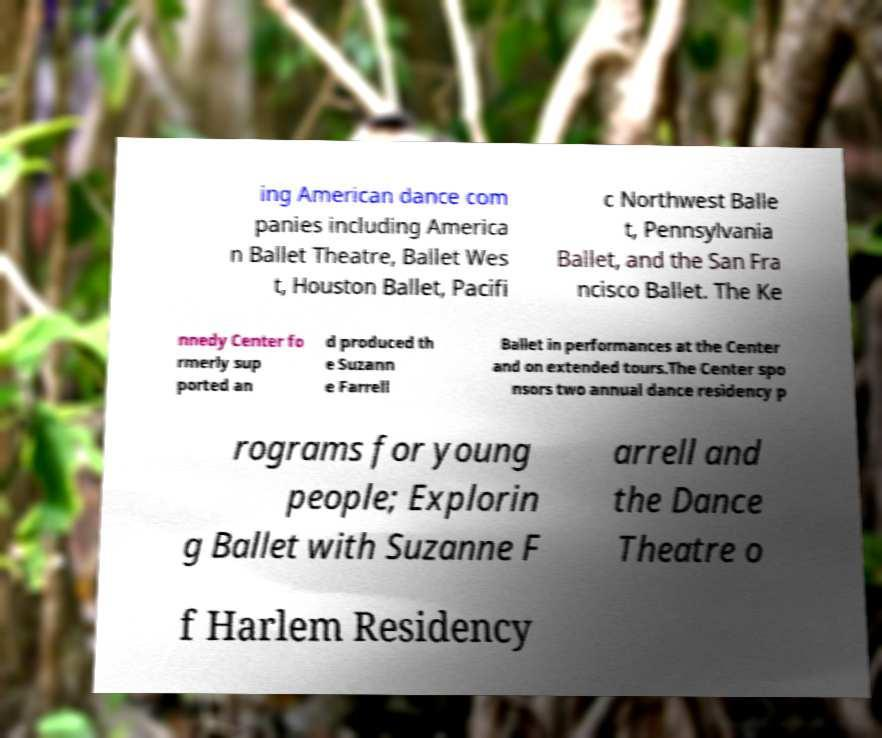Please identify and transcribe the text found in this image. ing American dance com panies including America n Ballet Theatre, Ballet Wes t, Houston Ballet, Pacifi c Northwest Balle t, Pennsylvania Ballet, and the San Fra ncisco Ballet. The Ke nnedy Center fo rmerly sup ported an d produced th e Suzann e Farrell Ballet in performances at the Center and on extended tours.The Center spo nsors two annual dance residency p rograms for young people; Explorin g Ballet with Suzanne F arrell and the Dance Theatre o f Harlem Residency 